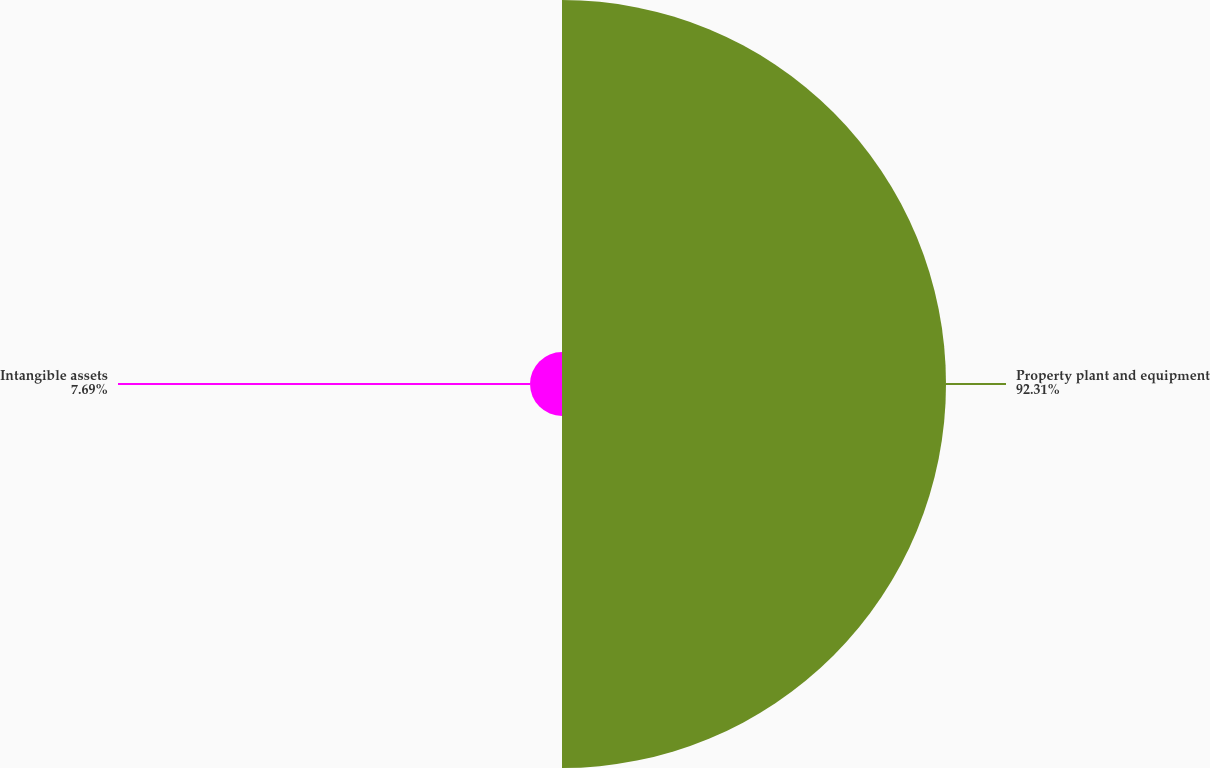Convert chart. <chart><loc_0><loc_0><loc_500><loc_500><pie_chart><fcel>Property plant and equipment<fcel>Intangible assets<nl><fcel>92.31%<fcel>7.69%<nl></chart> 